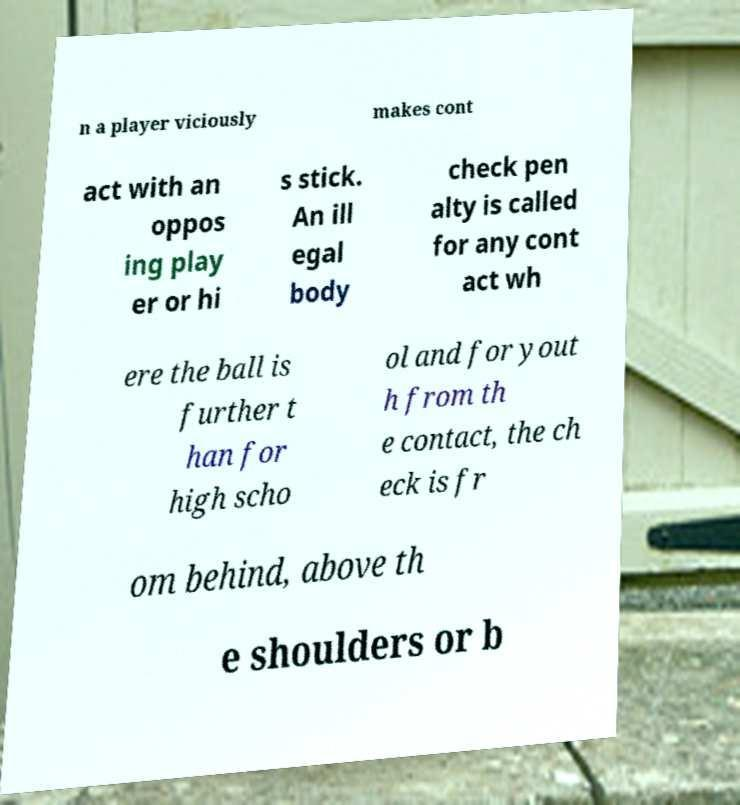Could you assist in decoding the text presented in this image and type it out clearly? n a player viciously makes cont act with an oppos ing play er or hi s stick. An ill egal body check pen alty is called for any cont act wh ere the ball is further t han for high scho ol and for yout h from th e contact, the ch eck is fr om behind, above th e shoulders or b 